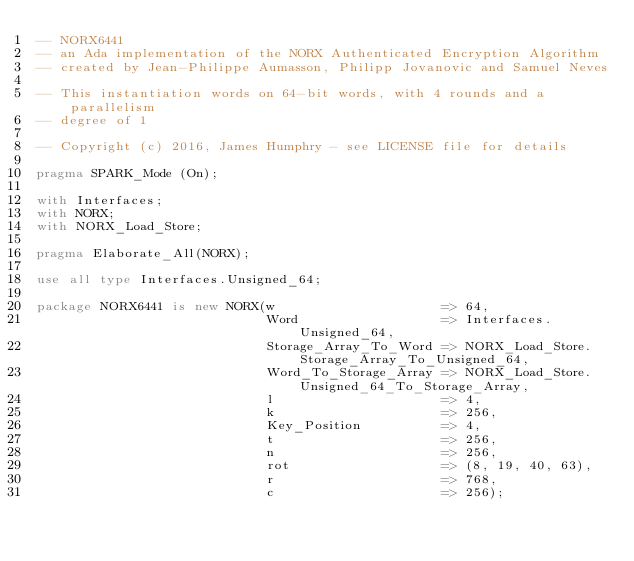Convert code to text. <code><loc_0><loc_0><loc_500><loc_500><_Ada_>-- NORX6441
-- an Ada implementation of the NORX Authenticated Encryption Algorithm
-- created by Jean-Philippe Aumasson, Philipp Jovanovic and Samuel Neves

-- This instantiation words on 64-bit words, with 4 rounds and a parallelism
-- degree of 1

-- Copyright (c) 2016, James Humphry - see LICENSE file for details

pragma SPARK_Mode (On);

with Interfaces;
with NORX;
with NORX_Load_Store;

pragma Elaborate_All(NORX);

use all type Interfaces.Unsigned_64;

package NORX6441 is new NORX(w                     => 64,
                             Word                  => Interfaces.Unsigned_64,
                             Storage_Array_To_Word => NORX_Load_Store.Storage_Array_To_Unsigned_64,
                             Word_To_Storage_Array => NORX_Load_Store.Unsigned_64_To_Storage_Array,
                             l                     => 4,
                             k                     => 256,
                             Key_Position          => 4,
                             t                     => 256,
                             n                     => 256,
                             rot                   => (8, 19, 40, 63),
                             r                     => 768,
                             c                     => 256);
</code> 